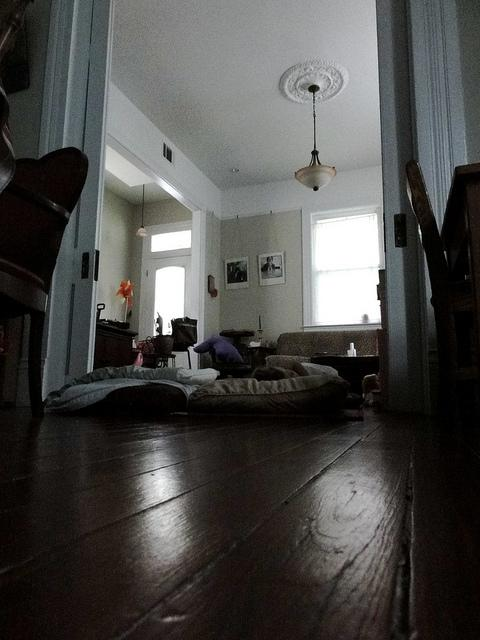What is the highest object in the room? ceiling lamp 